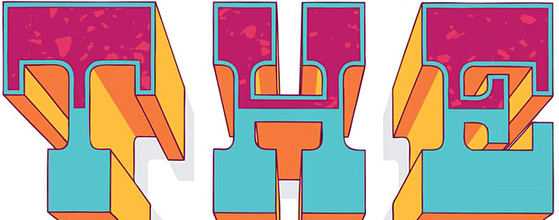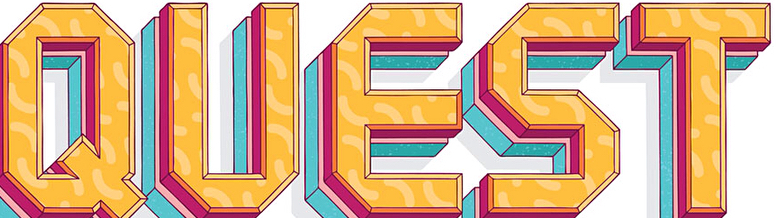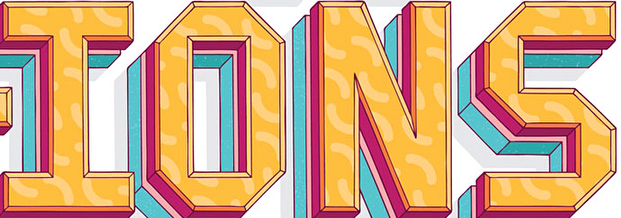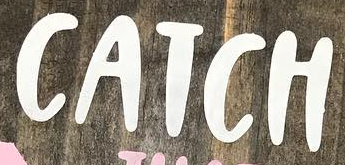What words are shown in these images in order, separated by a semicolon? THE; QUEST; IONS; CATCH 